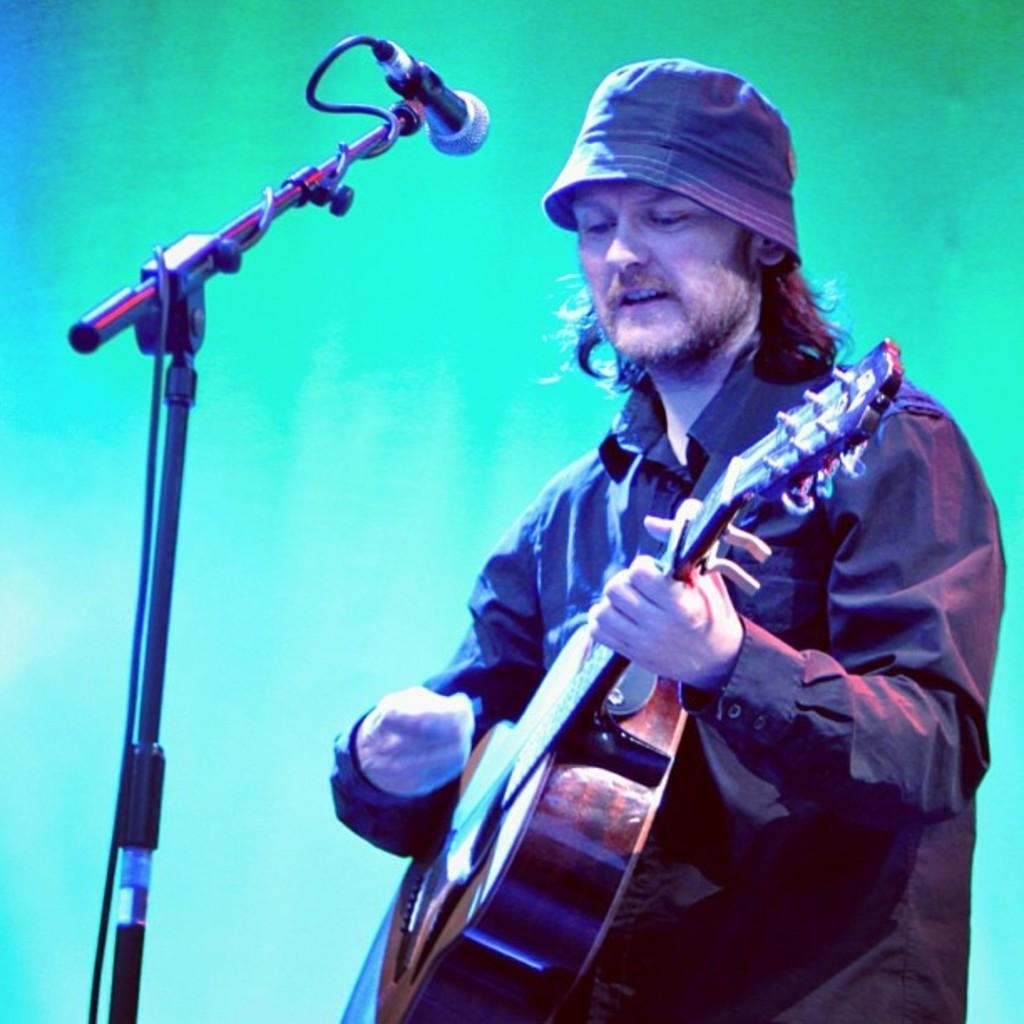What is the main subject of the image? The main subject of the image is a man. What is the man doing in the image? The man is standing and playing a guitar. What is the man wearing in the image? The man is wearing a black shirt and a hat. What is a feature of the man's appearance in the image? The man has long hair. What other object is present in the image? There is a microphone in the image. How is the microphone positioned in the image? The microphone is placed on a microphone stand. What type of office organization does the man belong to in the image? There is no indication of an office or organization in the image; it features a man playing a guitar and a microphone. 